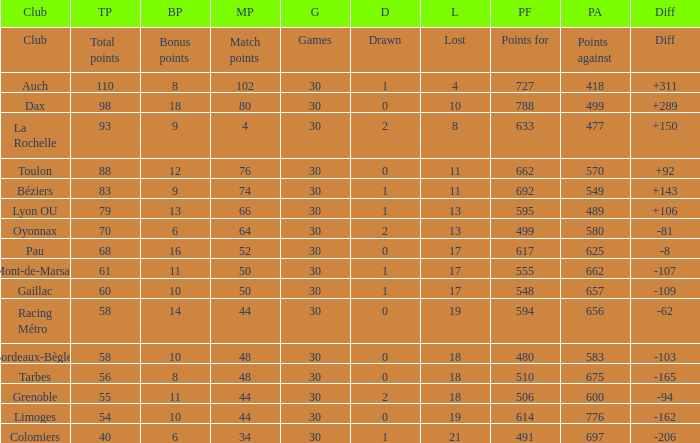What is the amount of match points for a club that lost 18 and has 11 bonus points? 44.0. 